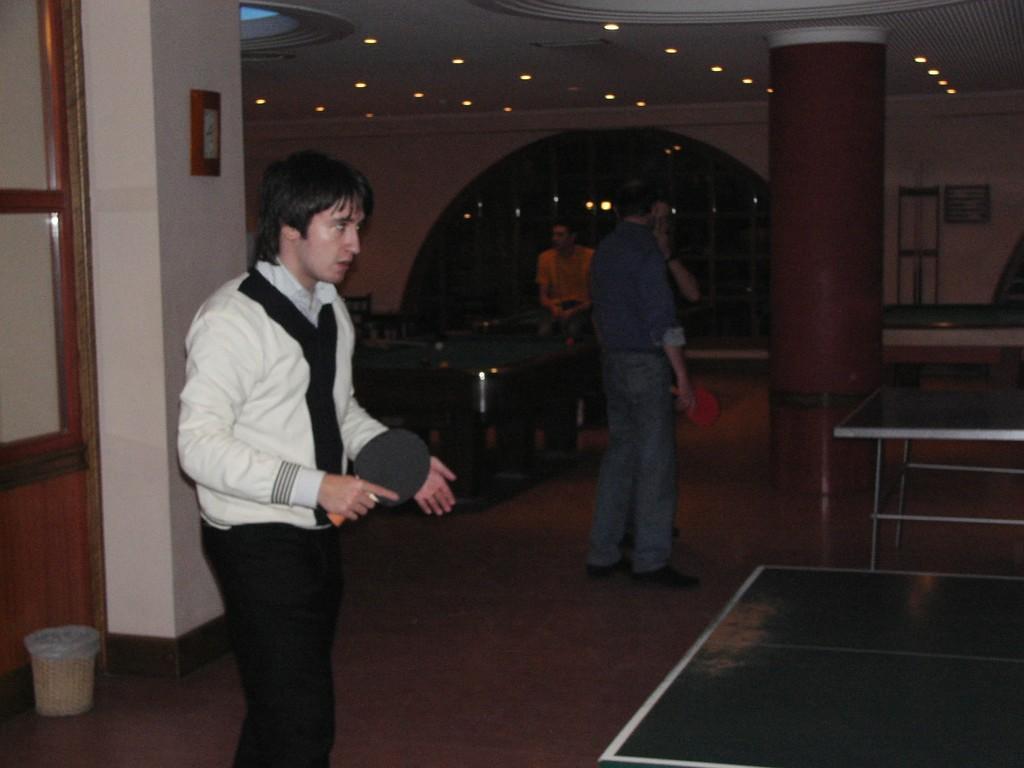Please provide a concise description of this image. In this picture we can see group of people, in the middle of the given image a person is holding a bat in his hand, in front of the table, in the background we can see couple of lights, besides to him we can see a cup on the table. 